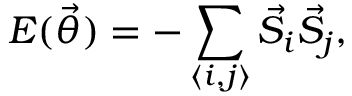<formula> <loc_0><loc_0><loc_500><loc_500>E ( \vec { \theta } ) = - \sum _ { \langle i , j \rangle } \vec { S } _ { i } \vec { S } _ { j } ,</formula> 